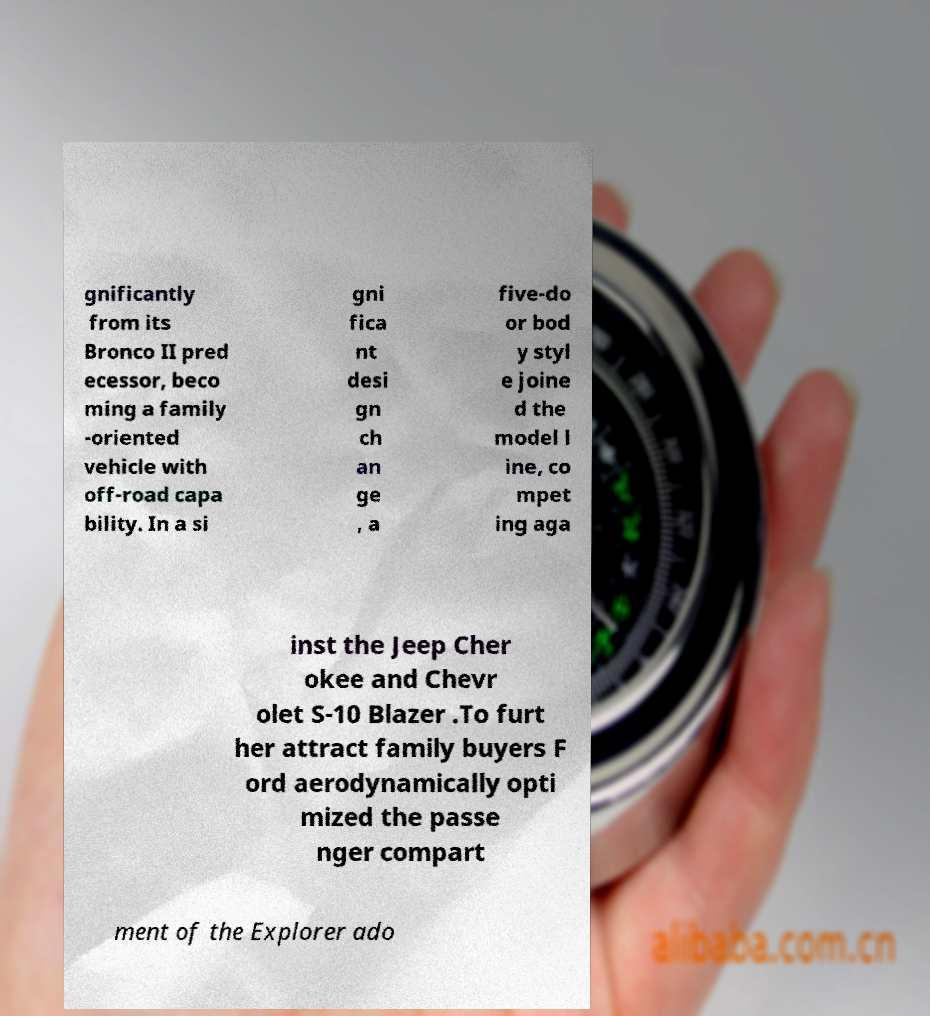There's text embedded in this image that I need extracted. Can you transcribe it verbatim? gnificantly from its Bronco II pred ecessor, beco ming a family -oriented vehicle with off-road capa bility. In a si gni fica nt desi gn ch an ge , a five-do or bod y styl e joine d the model l ine, co mpet ing aga inst the Jeep Cher okee and Chevr olet S-10 Blazer .To furt her attract family buyers F ord aerodynamically opti mized the passe nger compart ment of the Explorer ado 